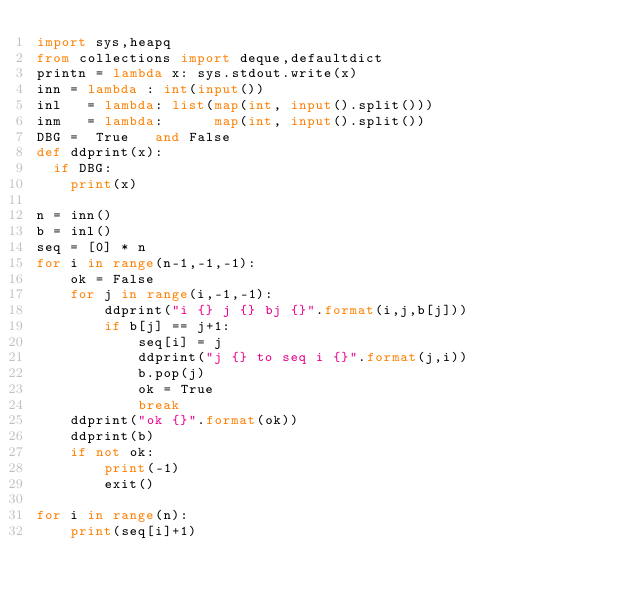Convert code to text. <code><loc_0><loc_0><loc_500><loc_500><_Python_>import sys,heapq
from collections import deque,defaultdict
printn = lambda x: sys.stdout.write(x)
inn = lambda : int(input())
inl   = lambda: list(map(int, input().split()))
inm   = lambda:      map(int, input().split())
DBG =  True   and False
def ddprint(x):
  if DBG:
    print(x)

n = inn()
b = inl()
seq = [0] * n
for i in range(n-1,-1,-1):
    ok = False
    for j in range(i,-1,-1):
        ddprint("i {} j {} bj {}".format(i,j,b[j]))
        if b[j] == j+1:
            seq[i] = j
            ddprint("j {} to seq i {}".format(j,i))
            b.pop(j)
            ok = True
            break
    ddprint("ok {}".format(ok))
    ddprint(b)
    if not ok:
        print(-1)
        exit()

for i in range(n):
    print(seq[i]+1)
</code> 